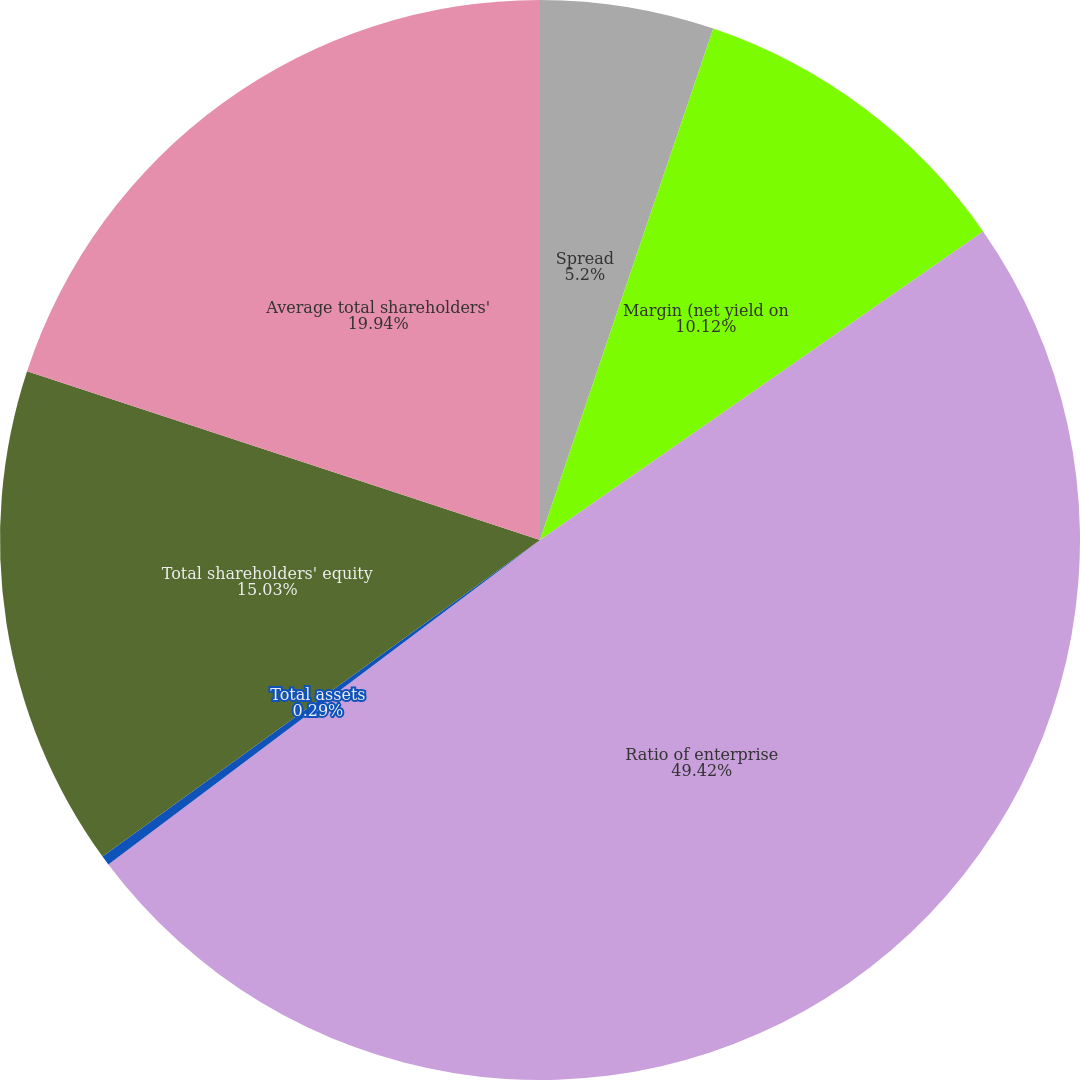Convert chart. <chart><loc_0><loc_0><loc_500><loc_500><pie_chart><fcel>Spread<fcel>Margin (net yield on<fcel>Ratio of enterprise<fcel>Total assets<fcel>Total shareholders' equity<fcel>Average total shareholders'<nl><fcel>5.2%<fcel>10.12%<fcel>49.42%<fcel>0.29%<fcel>15.03%<fcel>19.94%<nl></chart> 